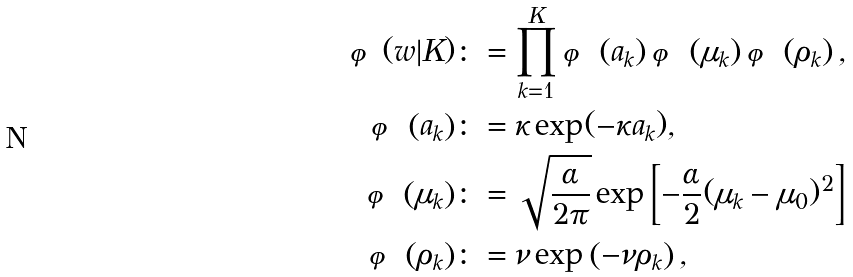<formula> <loc_0><loc_0><loc_500><loc_500>\varphi ( w | K ) & \colon = \prod _ { k = 1 } ^ { K } \varphi \left ( a _ { k } \right ) \varphi \left ( \mu _ { k } \right ) \varphi \left ( \rho _ { k } \right ) , \\ \varphi \left ( a _ { k } \right ) & \colon = \kappa \exp ( - \kappa a _ { k } ) , \\ \varphi \left ( \mu _ { k } \right ) & \colon = \sqrt { \frac { \alpha } { 2 \pi } } \exp \left [ - \frac { \alpha } { 2 } ( \mu _ { k } - \mu _ { 0 } ) ^ { 2 } \right ] \\ \varphi \left ( \rho _ { k } \right ) & \colon = \nu \exp \left ( - \nu \rho _ { k } \right ) ,</formula> 